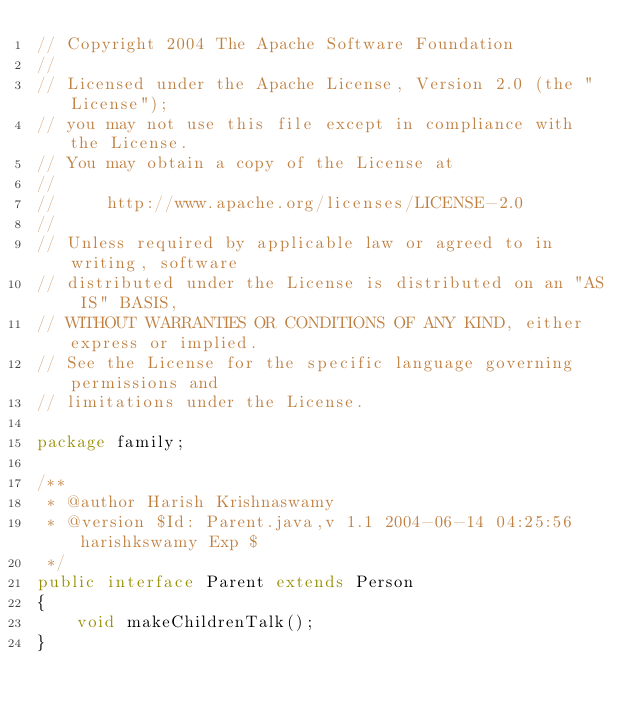<code> <loc_0><loc_0><loc_500><loc_500><_Java_>// Copyright 2004 The Apache Software Foundation
//
// Licensed under the Apache License, Version 2.0 (the "License");
// you may not use this file except in compliance with the License.
// You may obtain a copy of the License at
//
//     http://www.apache.org/licenses/LICENSE-2.0
//
// Unless required by applicable law or agreed to in writing, software
// distributed under the License is distributed on an "AS IS" BASIS,
// WITHOUT WARRANTIES OR CONDITIONS OF ANY KIND, either express or implied.
// See the License for the specific language governing permissions and
// limitations under the License.

package family;

/**
 * @author Harish Krishnaswamy
 * @version $Id: Parent.java,v 1.1 2004-06-14 04:25:56 harishkswamy Exp $
 */
public interface Parent extends Person
{
    void makeChildrenTalk();
}
</code> 